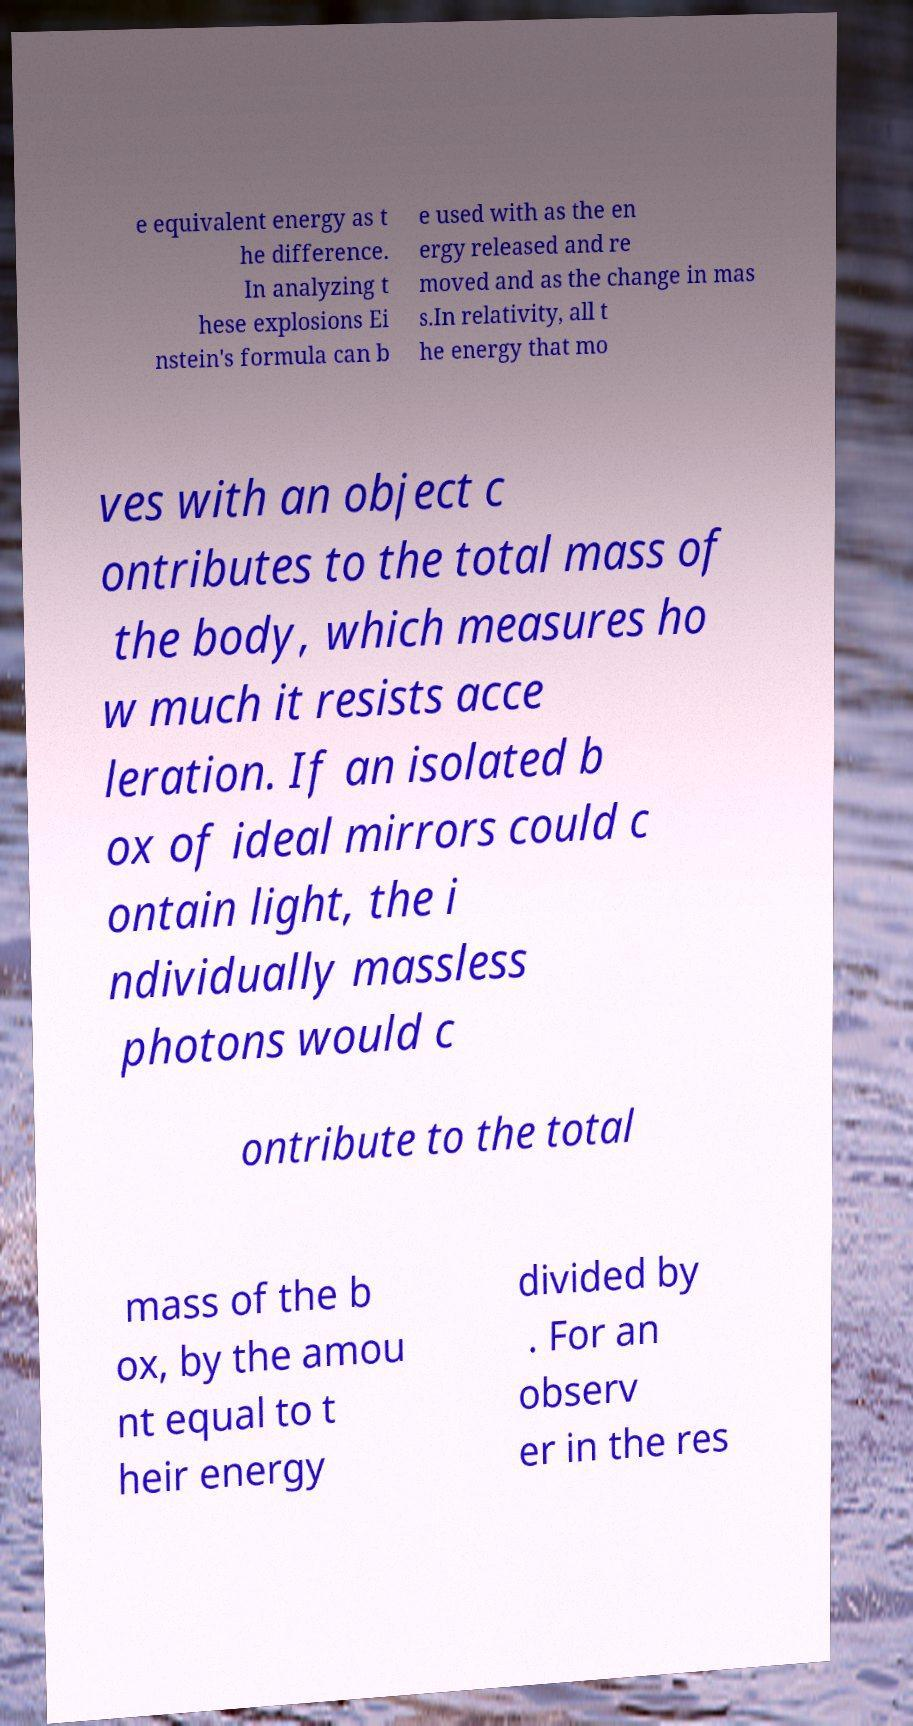For documentation purposes, I need the text within this image transcribed. Could you provide that? e equivalent energy as t he difference. In analyzing t hese explosions Ei nstein's formula can b e used with as the en ergy released and re moved and as the change in mas s.In relativity, all t he energy that mo ves with an object c ontributes to the total mass of the body, which measures ho w much it resists acce leration. If an isolated b ox of ideal mirrors could c ontain light, the i ndividually massless photons would c ontribute to the total mass of the b ox, by the amou nt equal to t heir energy divided by . For an observ er in the res 